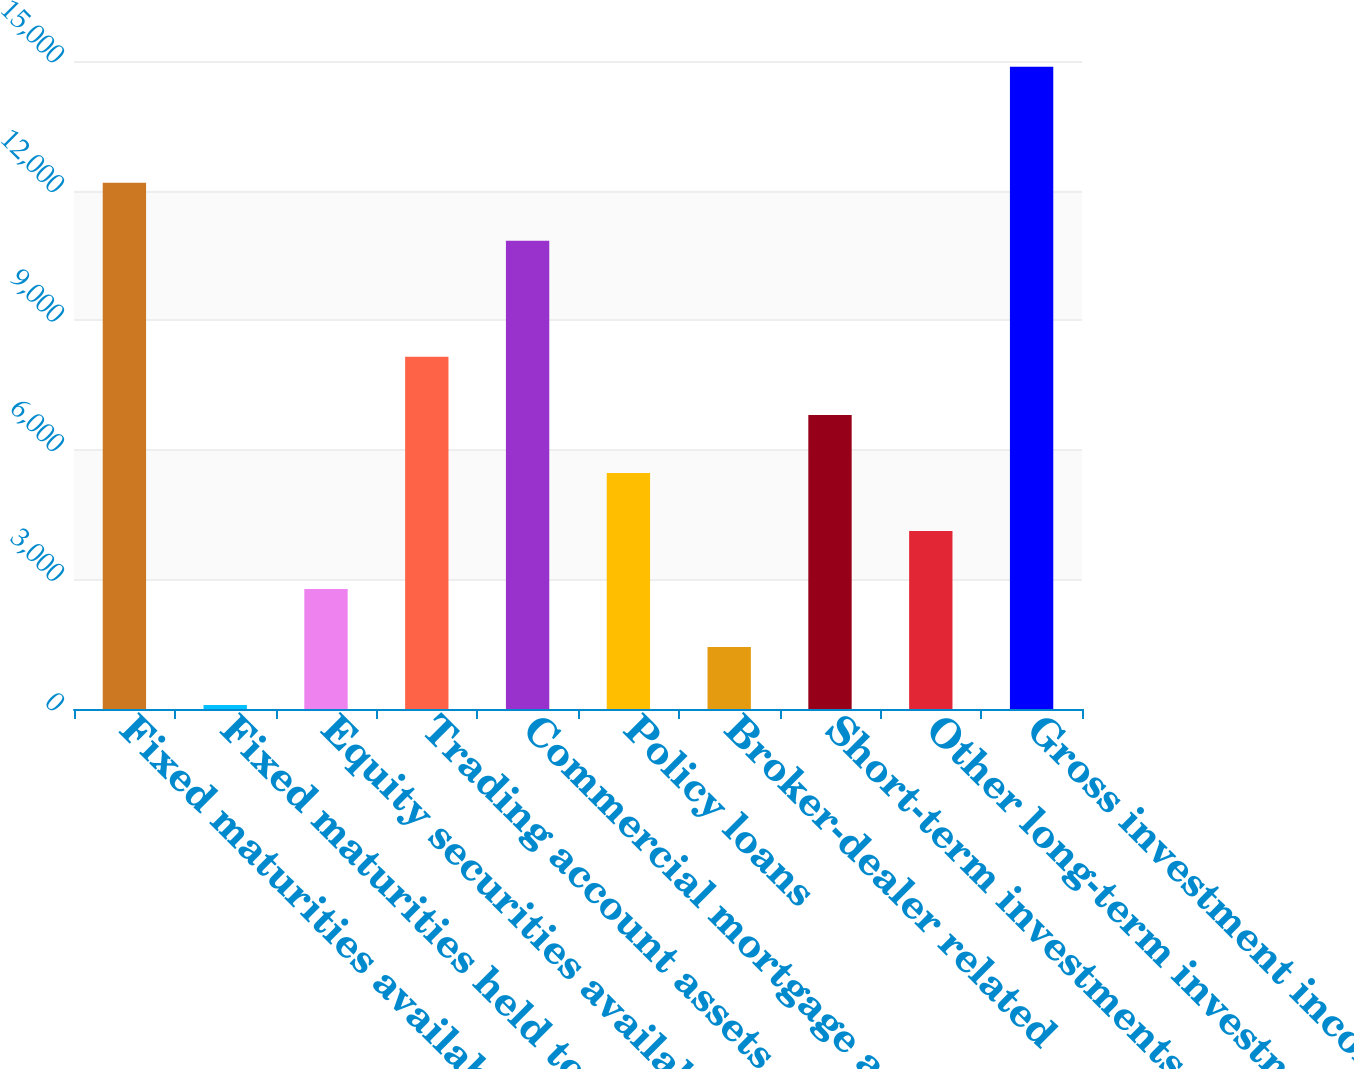<chart> <loc_0><loc_0><loc_500><loc_500><bar_chart><fcel>Fixed maturities available for<fcel>Fixed maturities held to<fcel>Equity securities available<fcel>Trading account assets<fcel>Commercial mortgage and other<fcel>Policy loans<fcel>Broker-dealer related<fcel>Short-term investments and<fcel>Other long-term investments<fcel>Gross investment income<nl><fcel>12182.4<fcel>90<fcel>2777.2<fcel>8151.6<fcel>10838.8<fcel>5464.4<fcel>1433.6<fcel>6808<fcel>4120.8<fcel>14869.6<nl></chart> 